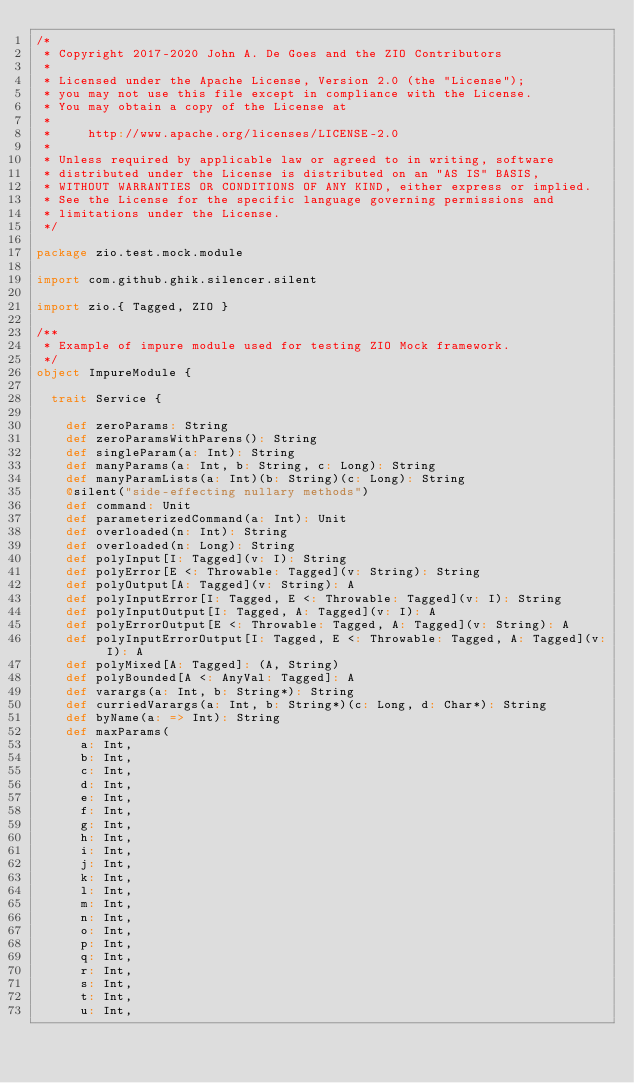<code> <loc_0><loc_0><loc_500><loc_500><_Scala_>/*
 * Copyright 2017-2020 John A. De Goes and the ZIO Contributors
 *
 * Licensed under the Apache License, Version 2.0 (the "License");
 * you may not use this file except in compliance with the License.
 * You may obtain a copy of the License at
 *
 *     http://www.apache.org/licenses/LICENSE-2.0
 *
 * Unless required by applicable law or agreed to in writing, software
 * distributed under the License is distributed on an "AS IS" BASIS,
 * WITHOUT WARRANTIES OR CONDITIONS OF ANY KIND, either express or implied.
 * See the License for the specific language governing permissions and
 * limitations under the License.
 */

package zio.test.mock.module

import com.github.ghik.silencer.silent

import zio.{ Tagged, ZIO }

/**
 * Example of impure module used for testing ZIO Mock framework.
 */
object ImpureModule {

  trait Service {

    def zeroParams: String
    def zeroParamsWithParens(): String
    def singleParam(a: Int): String
    def manyParams(a: Int, b: String, c: Long): String
    def manyParamLists(a: Int)(b: String)(c: Long): String
    @silent("side-effecting nullary methods")
    def command: Unit
    def parameterizedCommand(a: Int): Unit
    def overloaded(n: Int): String
    def overloaded(n: Long): String
    def polyInput[I: Tagged](v: I): String
    def polyError[E <: Throwable: Tagged](v: String): String
    def polyOutput[A: Tagged](v: String): A
    def polyInputError[I: Tagged, E <: Throwable: Tagged](v: I): String
    def polyInputOutput[I: Tagged, A: Tagged](v: I): A
    def polyErrorOutput[E <: Throwable: Tagged, A: Tagged](v: String): A
    def polyInputErrorOutput[I: Tagged, E <: Throwable: Tagged, A: Tagged](v: I): A
    def polyMixed[A: Tagged]: (A, String)
    def polyBounded[A <: AnyVal: Tagged]: A
    def varargs(a: Int, b: String*): String
    def curriedVarargs(a: Int, b: String*)(c: Long, d: Char*): String
    def byName(a: => Int): String
    def maxParams(
      a: Int,
      b: Int,
      c: Int,
      d: Int,
      e: Int,
      f: Int,
      g: Int,
      h: Int,
      i: Int,
      j: Int,
      k: Int,
      l: Int,
      m: Int,
      n: Int,
      o: Int,
      p: Int,
      q: Int,
      r: Int,
      s: Int,
      t: Int,
      u: Int,</code> 